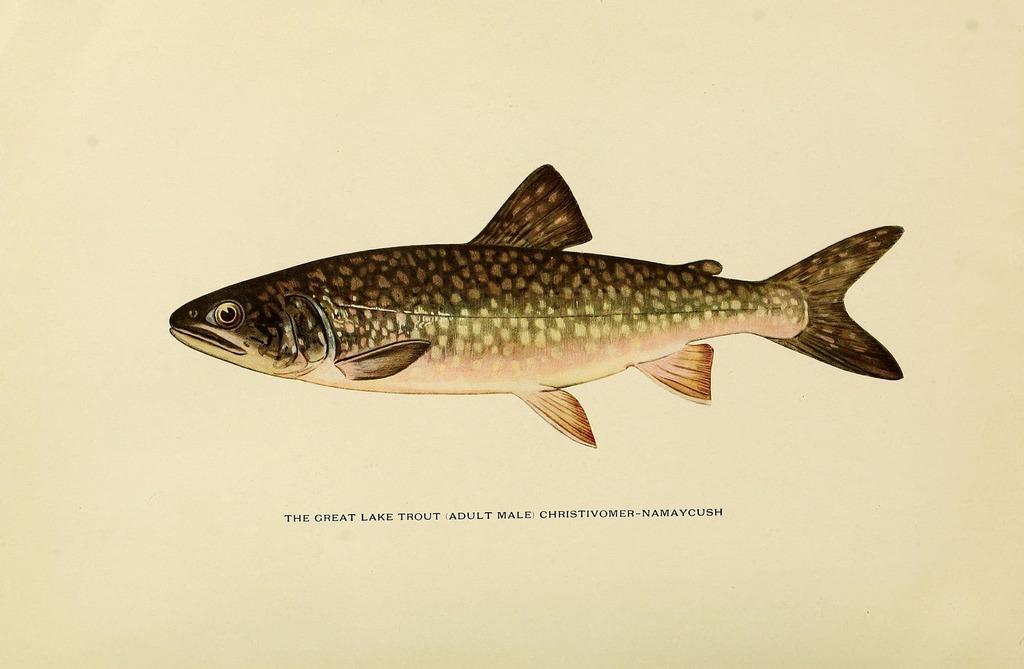Describe this image in one or two sentences. In the image there is a print of a fish on a paper with some text below it. 